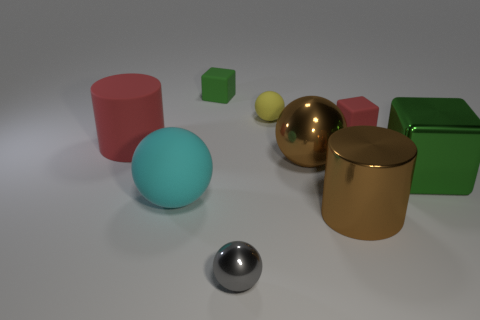What is the shape of the thing that is the same color as the large shiny ball?
Keep it short and to the point. Cylinder. Is the shape of the small gray shiny thing the same as the cyan thing?
Your answer should be very brief. Yes. How many big brown objects are there?
Offer a very short reply. 2. There is a red object that is made of the same material as the large red cylinder; what is its shape?
Your answer should be very brief. Cube. There is a big matte object that is behind the green shiny object; is it the same color as the tiny matte object right of the brown cylinder?
Ensure brevity in your answer.  Yes. Is the number of small yellow things that are in front of the brown metallic cylinder the same as the number of gray spheres?
Ensure brevity in your answer.  No. What number of metallic objects are on the left side of the large brown metal sphere?
Keep it short and to the point. 1. What size is the yellow ball?
Give a very brief answer. Small. There is a small ball that is made of the same material as the big brown ball; what is its color?
Keep it short and to the point. Gray. How many rubber cylinders are the same size as the green metallic cube?
Your response must be concise. 1. 